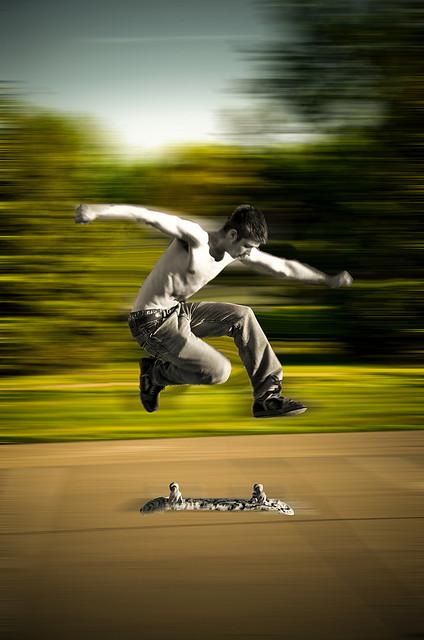Are they racing on a dirt track or asphalt?
Concise answer only. Asphalt. Is the boy wearing a shirt?
Be succinct. No. What kind of skateboarding trick is he attempting?
Keep it brief. Jump. Is the boy jumping?
Write a very short answer. Yes. Is he wearing a helmet?
Keep it brief. No. 